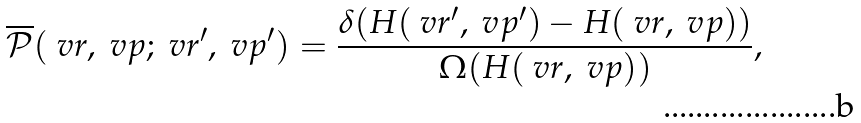Convert formula to latex. <formula><loc_0><loc_0><loc_500><loc_500>\overline { \mathcal { P } } ( \ v r , \ v p ; \ v r ^ { \prime } , \ v p ^ { \prime } ) = \frac { \delta ( H ( \ v r ^ { \prime } , \ v p ^ { \prime } ) - H ( \ v r , \ v p ) ) } { \Omega ( H ( \ v r , \ v p ) ) } ,</formula> 